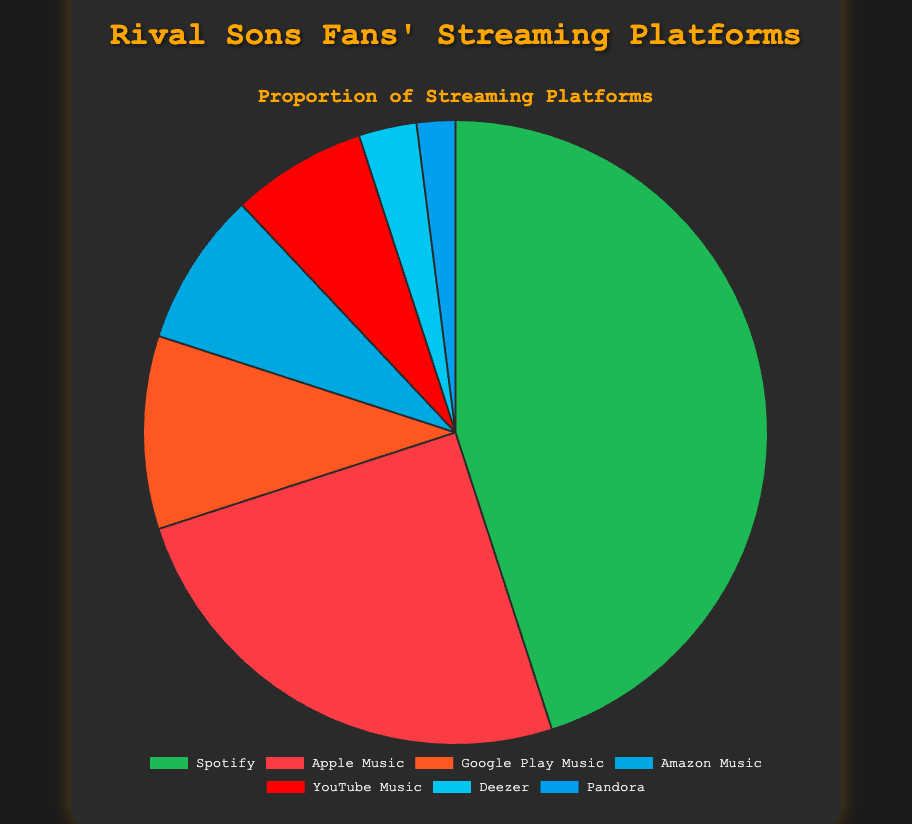Which music streaming platform is the most popular among Rival Sons fans? The pie chart shows different slices representing each platform, with Spotify having the largest slice.
Answer: Spotify Which two platforms combined make up more than half of the total usage among Rival Sons fans? Adding the proportions of Spotify (45%) and Apple Music (25%) gives a total of 70%, which is more than half.
Answer: Spotify and Apple Music What is the difference in usage percentage between Google Play Music and Amazon Music? Google Play Music has 10% usage and Amazon Music has 8% usage. The difference is calculated as 10% - 8%.
Answer: 2% If you sum the usage percentages of the least three popular platforms, what portion of the chart do they represent? Deezer (3%), Pandora (2%), and YouTube Music (7%) are the least popular platforms. Summing these percentages: 3% + 2% + 7% = 12%.
Answer: 12% Is the proportion of YouTube Music users greater than that of users of both Deezer and Pandora combined? YouTube Music has a 7% slice, and Deezer and Pandora combined have 3% + 2% = 5%. Comparing 7% and 5%, YouTube Music is greater.
Answer: Yes What proportion of Rival Sons fans use streaming platforms other than Spotify and Apple Music? The remaining platforms are Google Play Music (10%), Amazon Music (8%), YouTube Music (7%), Deezer (3%), and Pandora (2%). Summing these gives: 10% + 8% + 7% + 3% + 2% = 30%.
Answer: 30% What is the combined proportion of users who use Spotify and Google Play Music? Spotify has a 45% usage proportion and Google Play Music has 10%. Summing these: 45% + 10% = 55%.
Answer: 55% Which platform has a smaller usage proportion: Apple Music or Amazon Music? Apple Music has a 25% usage proportion, while Amazon Music has 8%. Comparing these, Amazon Music has the smaller proportion.
Answer: Amazon Music How many times greater is Spotify's usage compared to Pandora's among Rival Sons fans? Spotify has a 45% usage proportion and Pandora has 2%. The ratio is 45% / 2% = 22.5 times.
Answer: 22.5 times If you create a new group consisting of Google Play Music and YouTube Music users, what is the total percentage usage of this group? Google Play Music users are 10% and YouTube Music users are 7%. Adding these: 10% + 7% = 17%.
Answer: 17% 